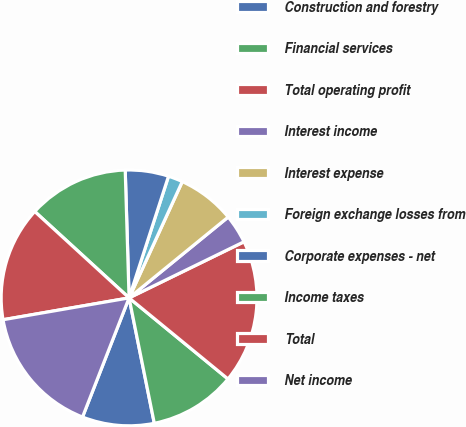<chart> <loc_0><loc_0><loc_500><loc_500><pie_chart><fcel>Construction and forestry<fcel>Financial services<fcel>Total operating profit<fcel>Interest income<fcel>Interest expense<fcel>Foreign exchange losses from<fcel>Corporate expenses - net<fcel>Income taxes<fcel>Total<fcel>Net income<nl><fcel>9.09%<fcel>10.91%<fcel>18.16%<fcel>3.66%<fcel>7.28%<fcel>1.84%<fcel>5.47%<fcel>12.72%<fcel>14.53%<fcel>16.34%<nl></chart> 